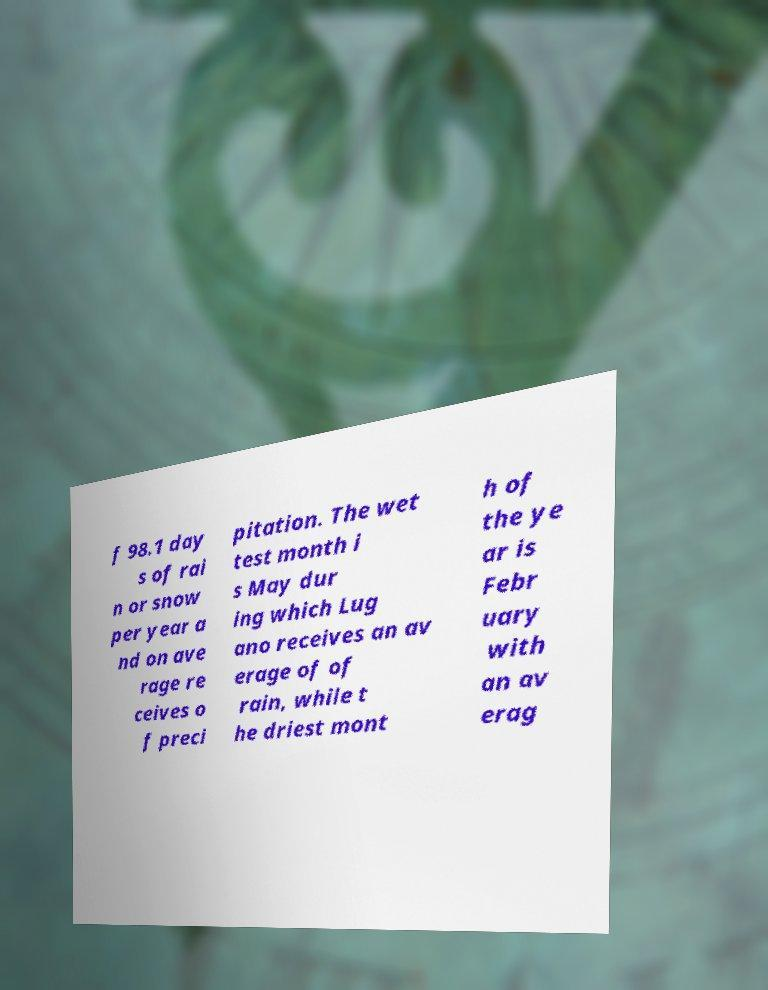What messages or text are displayed in this image? I need them in a readable, typed format. f 98.1 day s of rai n or snow per year a nd on ave rage re ceives o f preci pitation. The wet test month i s May dur ing which Lug ano receives an av erage of of rain, while t he driest mont h of the ye ar is Febr uary with an av erag 